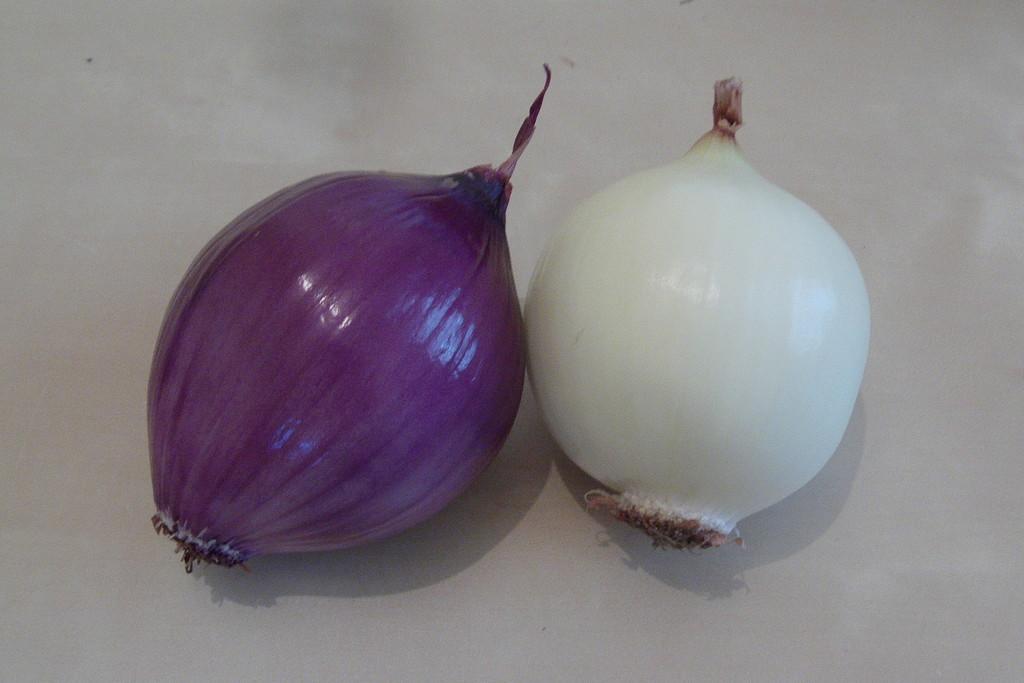In one or two sentences, can you explain what this image depicts? These are the two onions, this is in purple color and this is in white color. 